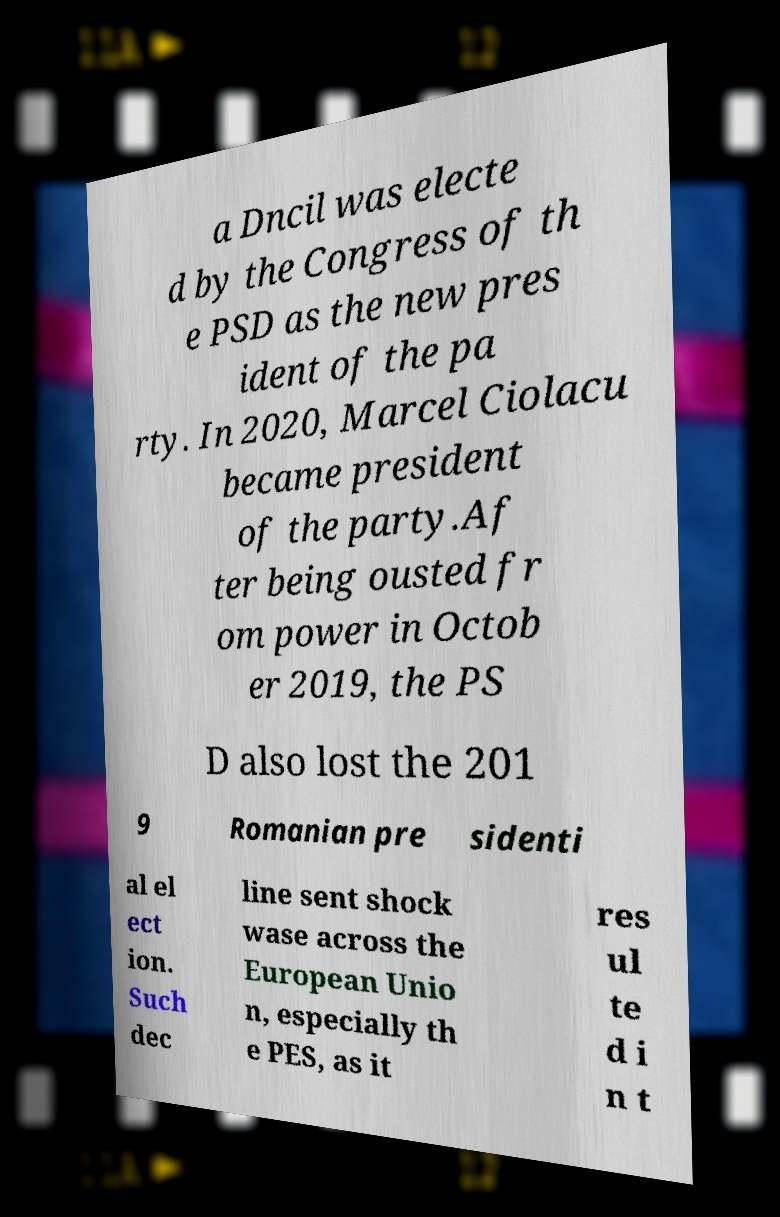I need the written content from this picture converted into text. Can you do that? a Dncil was electe d by the Congress of th e PSD as the new pres ident of the pa rty. In 2020, Marcel Ciolacu became president of the party.Af ter being ousted fr om power in Octob er 2019, the PS D also lost the 201 9 Romanian pre sidenti al el ect ion. Such dec line sent shock wase across the European Unio n, especially th e PES, as it res ul te d i n t 